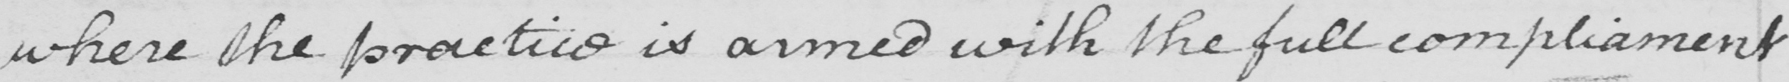Please transcribe the handwritten text in this image. where the practice is armed with the fullcompliament 